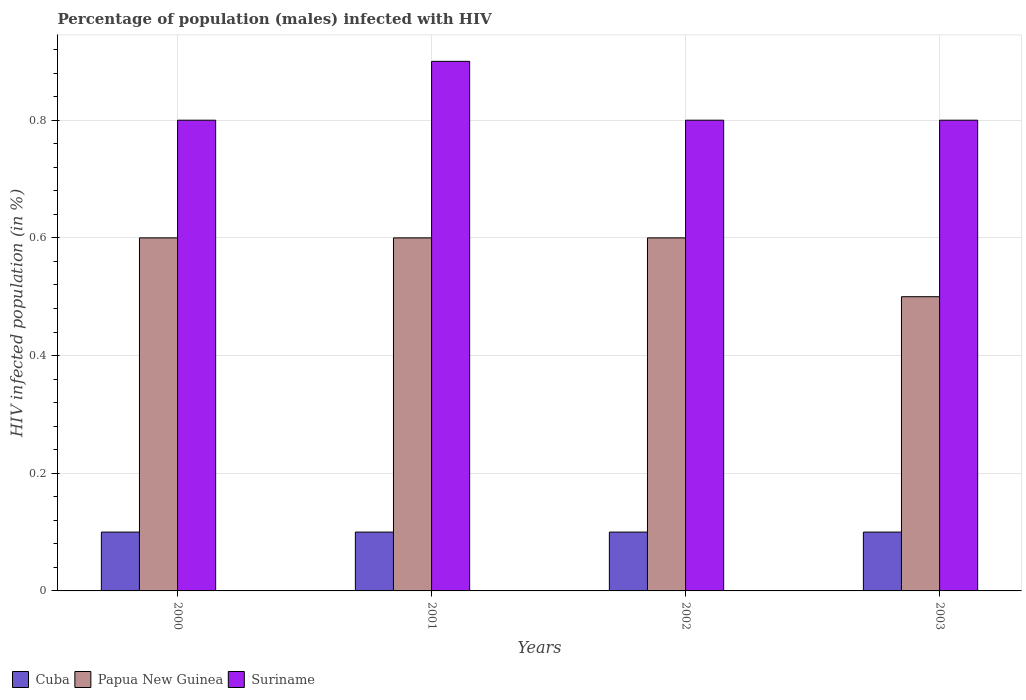How many different coloured bars are there?
Keep it short and to the point. 3. How many groups of bars are there?
Ensure brevity in your answer.  4. Are the number of bars per tick equal to the number of legend labels?
Provide a succinct answer. Yes. Are the number of bars on each tick of the X-axis equal?
Offer a very short reply. Yes. How many bars are there on the 2nd tick from the left?
Provide a succinct answer. 3. In how many cases, is the number of bars for a given year not equal to the number of legend labels?
Provide a succinct answer. 0. What is the percentage of HIV infected male population in Papua New Guinea in 2001?
Offer a very short reply. 0.6. Across all years, what is the maximum percentage of HIV infected male population in Papua New Guinea?
Provide a short and direct response. 0.6. In which year was the percentage of HIV infected male population in Papua New Guinea minimum?
Your answer should be compact. 2003. What is the total percentage of HIV infected male population in Suriname in the graph?
Provide a succinct answer. 3.3. What is the difference between the percentage of HIV infected male population in Suriname in 2001 and that in 2003?
Make the answer very short. 0.1. What is the difference between the percentage of HIV infected male population in Papua New Guinea in 2003 and the percentage of HIV infected male population in Suriname in 2002?
Keep it short and to the point. -0.3. What is the average percentage of HIV infected male population in Suriname per year?
Ensure brevity in your answer.  0.82. In the year 2000, what is the difference between the percentage of HIV infected male population in Suriname and percentage of HIV infected male population in Cuba?
Your answer should be very brief. 0.7. What is the ratio of the percentage of HIV infected male population in Cuba in 2000 to that in 2002?
Your response must be concise. 1. Is the percentage of HIV infected male population in Suriname in 2001 less than that in 2002?
Your answer should be very brief. No. Is the difference between the percentage of HIV infected male population in Suriname in 2000 and 2002 greater than the difference between the percentage of HIV infected male population in Cuba in 2000 and 2002?
Keep it short and to the point. No. What is the difference between the highest and the lowest percentage of HIV infected male population in Papua New Guinea?
Provide a succinct answer. 0.1. In how many years, is the percentage of HIV infected male population in Suriname greater than the average percentage of HIV infected male population in Suriname taken over all years?
Keep it short and to the point. 1. What does the 3rd bar from the left in 2002 represents?
Your answer should be compact. Suriname. What does the 2nd bar from the right in 2002 represents?
Offer a very short reply. Papua New Guinea. What is the difference between two consecutive major ticks on the Y-axis?
Your answer should be compact. 0.2. Does the graph contain grids?
Your answer should be very brief. Yes. Where does the legend appear in the graph?
Your answer should be compact. Bottom left. How are the legend labels stacked?
Make the answer very short. Horizontal. What is the title of the graph?
Your response must be concise. Percentage of population (males) infected with HIV. Does "Pacific island small states" appear as one of the legend labels in the graph?
Your response must be concise. No. What is the label or title of the X-axis?
Your answer should be very brief. Years. What is the label or title of the Y-axis?
Your answer should be very brief. HIV infected population (in %). What is the HIV infected population (in %) in Suriname in 2000?
Provide a short and direct response. 0.8. What is the HIV infected population (in %) of Suriname in 2003?
Provide a succinct answer. 0.8. What is the total HIV infected population (in %) in Cuba in the graph?
Ensure brevity in your answer.  0.4. What is the total HIV infected population (in %) of Papua New Guinea in the graph?
Offer a very short reply. 2.3. What is the difference between the HIV infected population (in %) in Suriname in 2000 and that in 2002?
Ensure brevity in your answer.  0. What is the difference between the HIV infected population (in %) of Cuba in 2000 and that in 2003?
Offer a very short reply. 0. What is the difference between the HIV infected population (in %) in Cuba in 2001 and that in 2002?
Your response must be concise. 0. What is the difference between the HIV infected population (in %) in Cuba in 2002 and that in 2003?
Offer a terse response. 0. What is the difference between the HIV infected population (in %) in Cuba in 2000 and the HIV infected population (in %) in Papua New Guinea in 2001?
Give a very brief answer. -0.5. What is the difference between the HIV infected population (in %) of Cuba in 2000 and the HIV infected population (in %) of Suriname in 2002?
Provide a short and direct response. -0.7. What is the difference between the HIV infected population (in %) of Papua New Guinea in 2000 and the HIV infected population (in %) of Suriname in 2002?
Provide a succinct answer. -0.2. What is the difference between the HIV infected population (in %) in Papua New Guinea in 2000 and the HIV infected population (in %) in Suriname in 2003?
Offer a terse response. -0.2. What is the difference between the HIV infected population (in %) in Cuba in 2001 and the HIV infected population (in %) in Papua New Guinea in 2002?
Make the answer very short. -0.5. What is the difference between the HIV infected population (in %) in Cuba in 2001 and the HIV infected population (in %) in Suriname in 2002?
Keep it short and to the point. -0.7. What is the difference between the HIV infected population (in %) of Cuba in 2001 and the HIV infected population (in %) of Suriname in 2003?
Give a very brief answer. -0.7. What is the difference between the HIV infected population (in %) of Cuba in 2002 and the HIV infected population (in %) of Papua New Guinea in 2003?
Make the answer very short. -0.4. What is the difference between the HIV infected population (in %) of Cuba in 2002 and the HIV infected population (in %) of Suriname in 2003?
Give a very brief answer. -0.7. What is the difference between the HIV infected population (in %) of Papua New Guinea in 2002 and the HIV infected population (in %) of Suriname in 2003?
Your answer should be compact. -0.2. What is the average HIV infected population (in %) of Papua New Guinea per year?
Offer a very short reply. 0.57. What is the average HIV infected population (in %) of Suriname per year?
Provide a succinct answer. 0.82. In the year 2000, what is the difference between the HIV infected population (in %) in Cuba and HIV infected population (in %) in Papua New Guinea?
Offer a very short reply. -0.5. In the year 2000, what is the difference between the HIV infected population (in %) in Cuba and HIV infected population (in %) in Suriname?
Provide a short and direct response. -0.7. In the year 2001, what is the difference between the HIV infected population (in %) in Cuba and HIV infected population (in %) in Suriname?
Keep it short and to the point. -0.8. In the year 2002, what is the difference between the HIV infected population (in %) of Cuba and HIV infected population (in %) of Papua New Guinea?
Your answer should be very brief. -0.5. In the year 2003, what is the difference between the HIV infected population (in %) in Cuba and HIV infected population (in %) in Papua New Guinea?
Make the answer very short. -0.4. In the year 2003, what is the difference between the HIV infected population (in %) in Cuba and HIV infected population (in %) in Suriname?
Make the answer very short. -0.7. In the year 2003, what is the difference between the HIV infected population (in %) of Papua New Guinea and HIV infected population (in %) of Suriname?
Your answer should be very brief. -0.3. What is the ratio of the HIV infected population (in %) in Cuba in 2000 to that in 2001?
Give a very brief answer. 1. What is the ratio of the HIV infected population (in %) of Papua New Guinea in 2000 to that in 2001?
Provide a succinct answer. 1. What is the ratio of the HIV infected population (in %) of Suriname in 2000 to that in 2001?
Your answer should be very brief. 0.89. What is the ratio of the HIV infected population (in %) in Cuba in 2000 to that in 2002?
Your answer should be very brief. 1. What is the ratio of the HIV infected population (in %) of Papua New Guinea in 2000 to that in 2002?
Your answer should be compact. 1. What is the ratio of the HIV infected population (in %) in Suriname in 2000 to that in 2002?
Provide a succinct answer. 1. What is the ratio of the HIV infected population (in %) in Cuba in 2000 to that in 2003?
Make the answer very short. 1. What is the ratio of the HIV infected population (in %) in Suriname in 2001 to that in 2002?
Provide a succinct answer. 1.12. What is the ratio of the HIV infected population (in %) in Cuba in 2001 to that in 2003?
Your answer should be compact. 1. What is the ratio of the HIV infected population (in %) in Suriname in 2002 to that in 2003?
Ensure brevity in your answer.  1. What is the difference between the highest and the lowest HIV infected population (in %) of Cuba?
Make the answer very short. 0. What is the difference between the highest and the lowest HIV infected population (in %) of Papua New Guinea?
Your answer should be very brief. 0.1. What is the difference between the highest and the lowest HIV infected population (in %) of Suriname?
Provide a succinct answer. 0.1. 